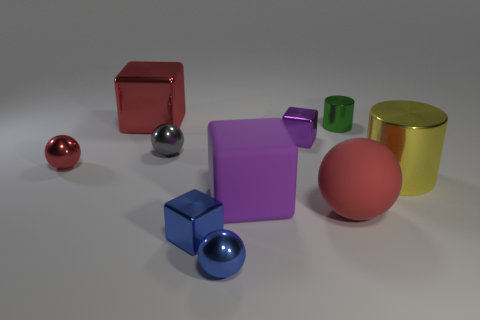Assuming these were real objects, what materials could they be made out of? Based on their appearances, these objects could be made from a range of real-world materials. The shiny finish on some suggests metals or polished stones, whereas the matte surfaces could be indicative of plastics or painted wood.  Looking at their surfaces, how would you describe their texture? The objects display an assortment of textures, with some showing specular highlights that suggest a smooth and reflective surface, while others have a more subdued look that could be perceived as soft or even slightly textured to the touch. 